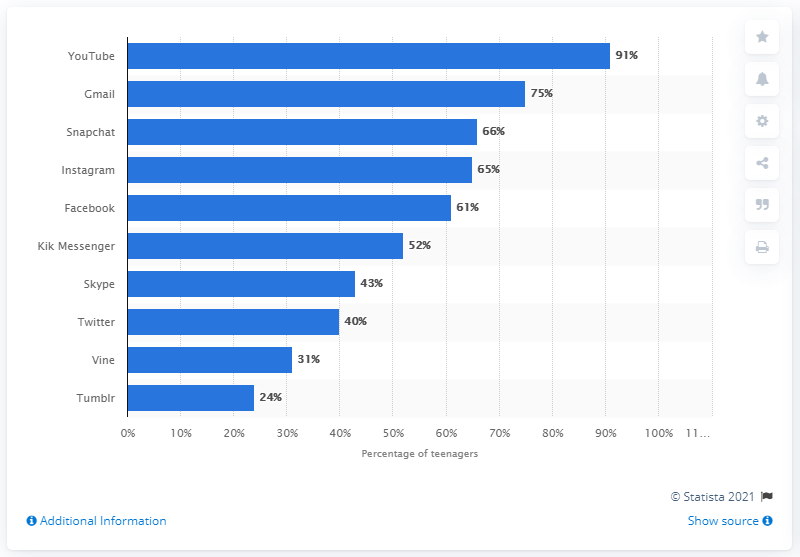Draw attention to some important aspects in this diagram. YouTube was the most widely used social media and networking site among teenagers in the United States as of June 2016. YouTube and Gmail were the two most commonly used social media and networking sites among teenagers in the United States as of June 2016. 